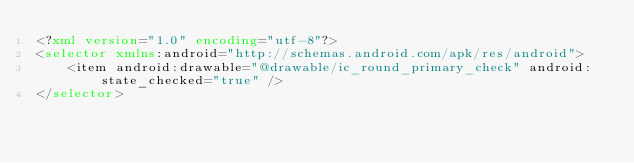<code> <loc_0><loc_0><loc_500><loc_500><_XML_><?xml version="1.0" encoding="utf-8"?>
<selector xmlns:android="http://schemas.android.com/apk/res/android">
    <item android:drawable="@drawable/ic_round_primary_check" android:state_checked="true" />
</selector>
</code> 